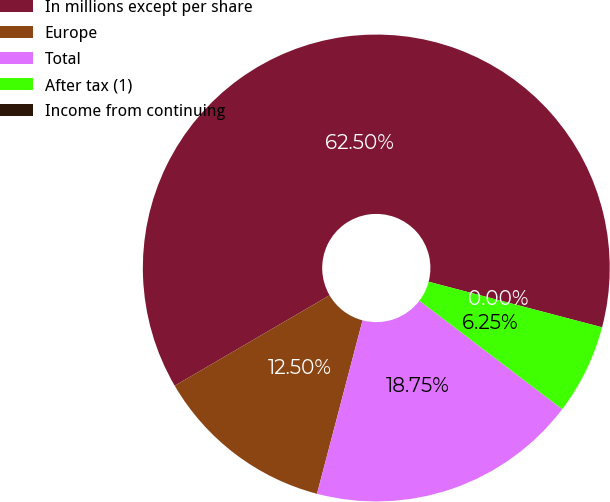Convert chart. <chart><loc_0><loc_0><loc_500><loc_500><pie_chart><fcel>In millions except per share<fcel>Europe<fcel>Total<fcel>After tax (1)<fcel>Income from continuing<nl><fcel>62.5%<fcel>12.5%<fcel>18.75%<fcel>6.25%<fcel>0.0%<nl></chart> 